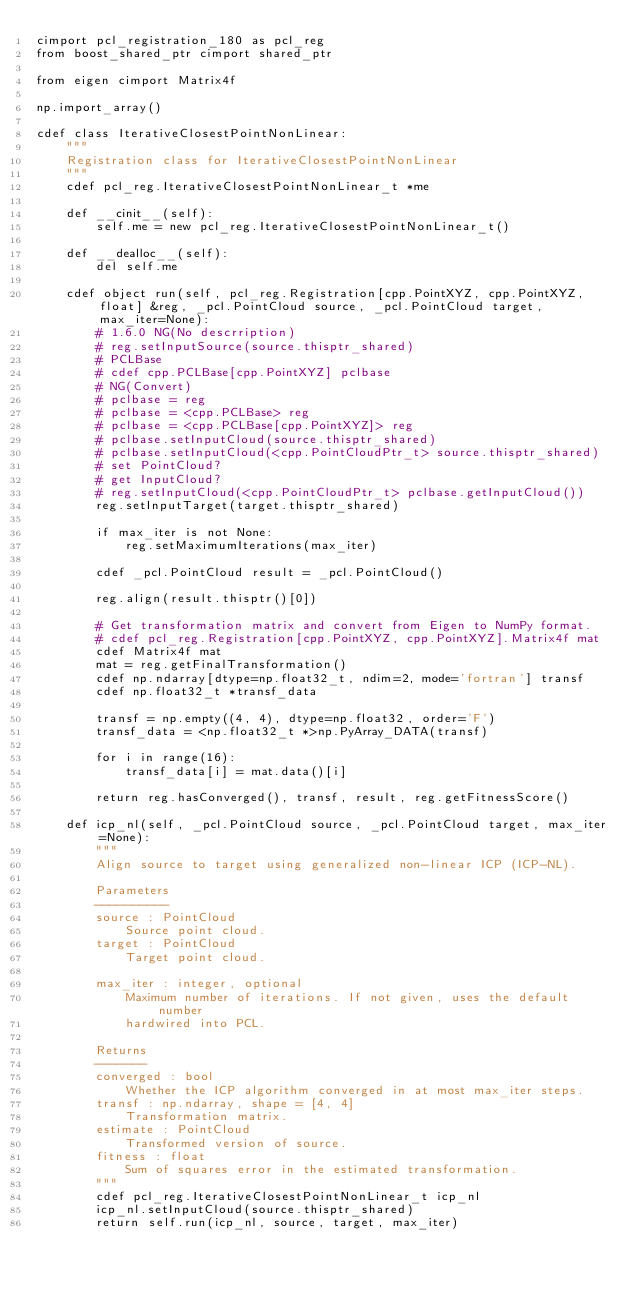Convert code to text. <code><loc_0><loc_0><loc_500><loc_500><_Cython_>cimport pcl_registration_180 as pcl_reg
from boost_shared_ptr cimport shared_ptr

from eigen cimport Matrix4f

np.import_array()

cdef class IterativeClosestPointNonLinear:
    """
    Registration class for IterativeClosestPointNonLinear
    """
    cdef pcl_reg.IterativeClosestPointNonLinear_t *me

    def __cinit__(self):
        self.me = new pcl_reg.IterativeClosestPointNonLinear_t()

    def __dealloc__(self):
        del self.me

    cdef object run(self, pcl_reg.Registration[cpp.PointXYZ, cpp.PointXYZ, float] &reg, _pcl.PointCloud source, _pcl.PointCloud target, max_iter=None):
        # 1.6.0 NG(No descrription)
        # reg.setInputSource(source.thisptr_shared)
        # PCLBase
        # cdef cpp.PCLBase[cpp.PointXYZ] pclbase
        # NG(Convert)
        # pclbase = reg
        # pclbase = <cpp.PCLBase> reg
        # pclbase = <cpp.PCLBase[cpp.PointXYZ]> reg
        # pclbase.setInputCloud(source.thisptr_shared)
        # pclbase.setInputCloud(<cpp.PointCloudPtr_t> source.thisptr_shared)
        # set PointCloud?
        # get InputCloud?
        # reg.setInputCloud(<cpp.PointCloudPtr_t> pclbase.getInputCloud())
        reg.setInputTarget(target.thisptr_shared)
        
        if max_iter is not None:
            reg.setMaximumIterations(max_iter)
        
        cdef _pcl.PointCloud result = _pcl.PointCloud()
        
        reg.align(result.thisptr()[0])
        
        # Get transformation matrix and convert from Eigen to NumPy format.
        # cdef pcl_reg.Registration[cpp.PointXYZ, cpp.PointXYZ].Matrix4f mat
        cdef Matrix4f mat
        mat = reg.getFinalTransformation()
        cdef np.ndarray[dtype=np.float32_t, ndim=2, mode='fortran'] transf
        cdef np.float32_t *transf_data
        
        transf = np.empty((4, 4), dtype=np.float32, order='F')
        transf_data = <np.float32_t *>np.PyArray_DATA(transf)
        
        for i in range(16):
            transf_data[i] = mat.data()[i]
        
        return reg.hasConverged(), transf, result, reg.getFitnessScore()

    def icp_nl(self, _pcl.PointCloud source, _pcl.PointCloud target, max_iter=None):
        """
        Align source to target using generalized non-linear ICP (ICP-NL).
        
        Parameters
        ----------
        source : PointCloud
            Source point cloud.
        target : PointCloud
            Target point cloud.
        
        max_iter : integer, optional
            Maximum number of iterations. If not given, uses the default number
            hardwired into PCL.
        
        Returns
        -------
        converged : bool
            Whether the ICP algorithm converged in at most max_iter steps.
        transf : np.ndarray, shape = [4, 4]
            Transformation matrix.
        estimate : PointCloud
            Transformed version of source.
        fitness : float
            Sum of squares error in the estimated transformation.
        """
        cdef pcl_reg.IterativeClosestPointNonLinear_t icp_nl
        icp_nl.setInputCloud(source.thisptr_shared)
        return self.run(icp_nl, source, target, max_iter)

</code> 